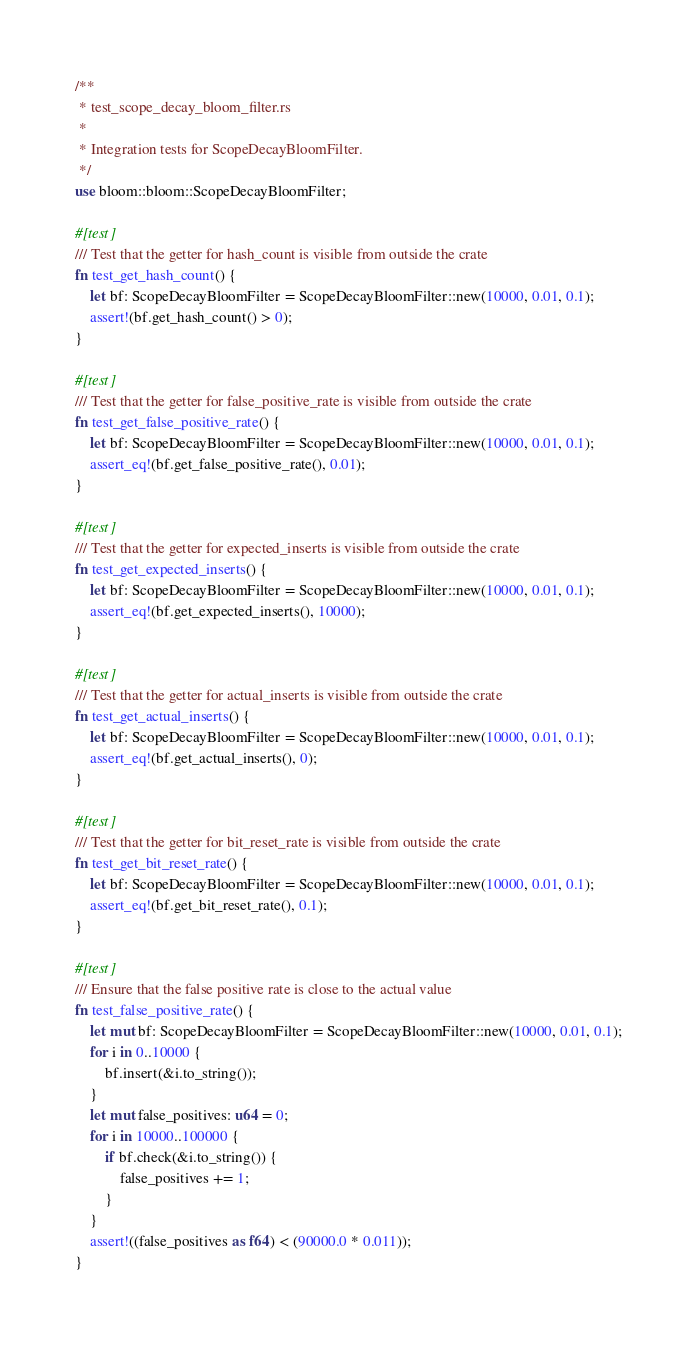Convert code to text. <code><loc_0><loc_0><loc_500><loc_500><_Rust_>/**
 * test_scope_decay_bloom_filter.rs
 *
 * Integration tests for ScopeDecayBloomFilter.
 */
use bloom::bloom::ScopeDecayBloomFilter;

#[test]
/// Test that the getter for hash_count is visible from outside the crate
fn test_get_hash_count() {
    let bf: ScopeDecayBloomFilter = ScopeDecayBloomFilter::new(10000, 0.01, 0.1);
    assert!(bf.get_hash_count() > 0);
}

#[test]
/// Test that the getter for false_positive_rate is visible from outside the crate
fn test_get_false_positive_rate() {
    let bf: ScopeDecayBloomFilter = ScopeDecayBloomFilter::new(10000, 0.01, 0.1);
    assert_eq!(bf.get_false_positive_rate(), 0.01);
}

#[test]
/// Test that the getter for expected_inserts is visible from outside the crate
fn test_get_expected_inserts() {
    let bf: ScopeDecayBloomFilter = ScopeDecayBloomFilter::new(10000, 0.01, 0.1);
    assert_eq!(bf.get_expected_inserts(), 10000);
}

#[test]
/// Test that the getter for actual_inserts is visible from outside the crate
fn test_get_actual_inserts() {
    let bf: ScopeDecayBloomFilter = ScopeDecayBloomFilter::new(10000, 0.01, 0.1);
    assert_eq!(bf.get_actual_inserts(), 0);
}

#[test]
/// Test that the getter for bit_reset_rate is visible from outside the crate
fn test_get_bit_reset_rate() {
    let bf: ScopeDecayBloomFilter = ScopeDecayBloomFilter::new(10000, 0.01, 0.1);
    assert_eq!(bf.get_bit_reset_rate(), 0.1);
}

#[test]
/// Ensure that the false positive rate is close to the actual value
fn test_false_positive_rate() {
    let mut bf: ScopeDecayBloomFilter = ScopeDecayBloomFilter::new(10000, 0.01, 0.1);
    for i in 0..10000 {
        bf.insert(&i.to_string());
    }
    let mut false_positives: u64 = 0;
    for i in 10000..100000 {
        if bf.check(&i.to_string()) {
            false_positives += 1;
        }
    }
    assert!((false_positives as f64) < (90000.0 * 0.011));
}
</code> 